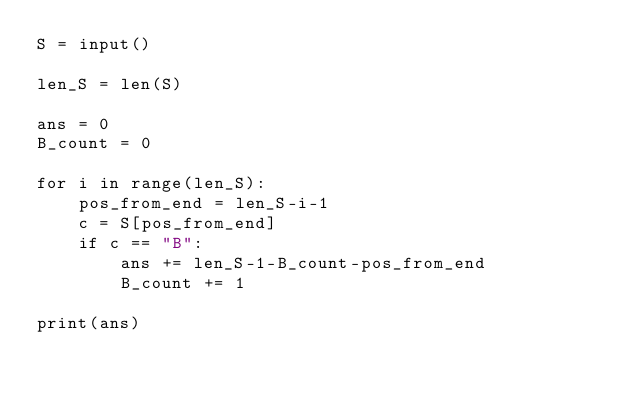Convert code to text. <code><loc_0><loc_0><loc_500><loc_500><_Python_>S = input()

len_S = len(S)

ans = 0
B_count = 0

for i in range(len_S):
    pos_from_end = len_S-i-1
    c = S[pos_from_end]
    if c == "B":
        ans += len_S-1-B_count-pos_from_end
        B_count += 1

print(ans)
</code> 